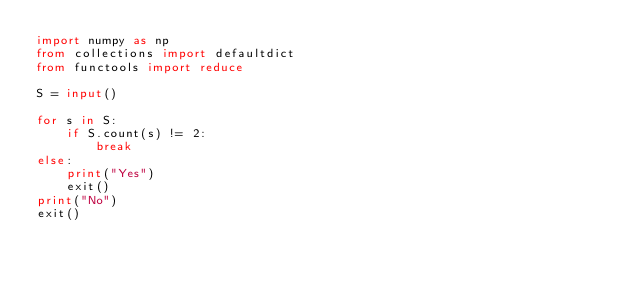<code> <loc_0><loc_0><loc_500><loc_500><_Python_>import numpy as np
from collections import defaultdict
from functools import reduce

S = input()

for s in S:
    if S.count(s) != 2:
        break
else:
    print("Yes")
    exit()
print("No")
exit()



</code> 